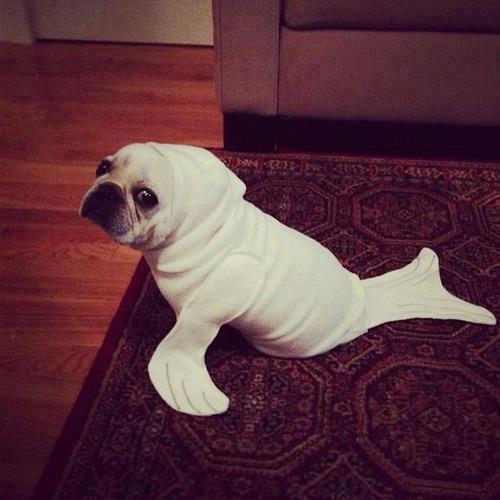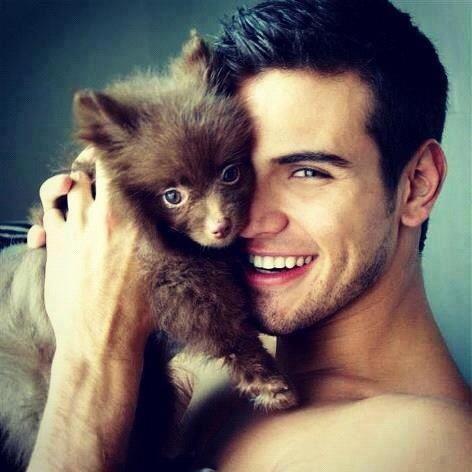The first image is the image on the left, the second image is the image on the right. Given the left and right images, does the statement "A person is holding the dog in the image on the right." hold true? Answer yes or no. Yes. The first image is the image on the left, the second image is the image on the right. For the images displayed, is the sentence "Each image contains one 'real' live spaniel with dry orange-and-white fur, and one dog is posed on folds of pale fabric." factually correct? Answer yes or no. No. 